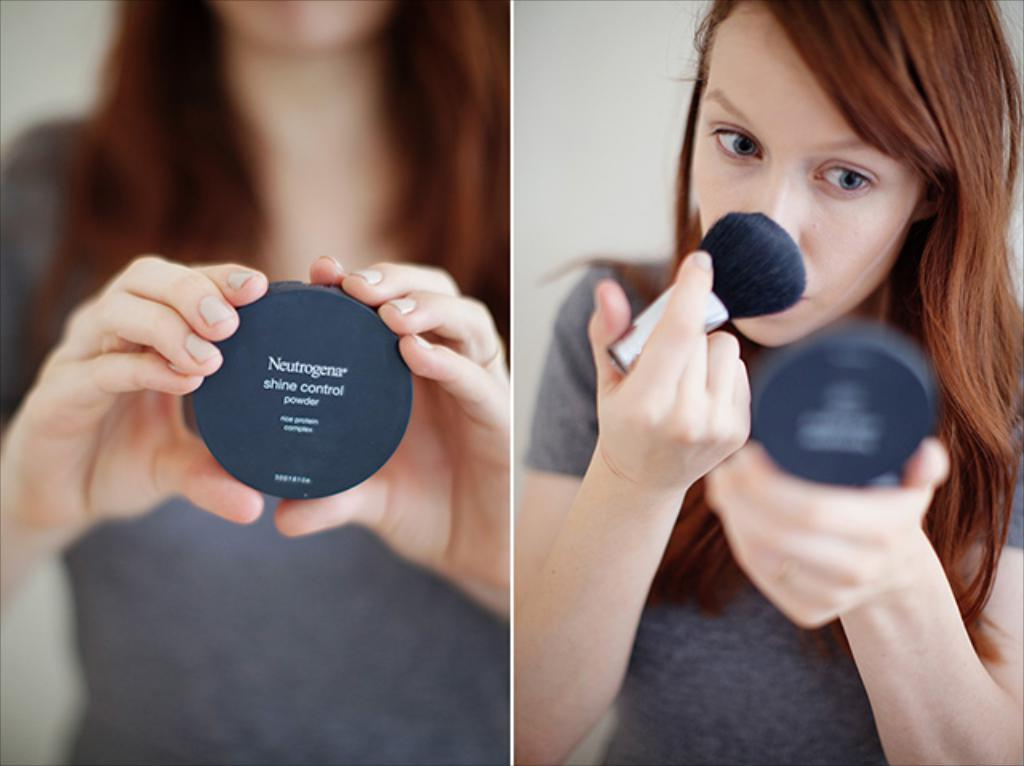<image>
Create a compact narrative representing the image presented. a girl with a large brush is applying Neutrogena shine control powder from a black compact 